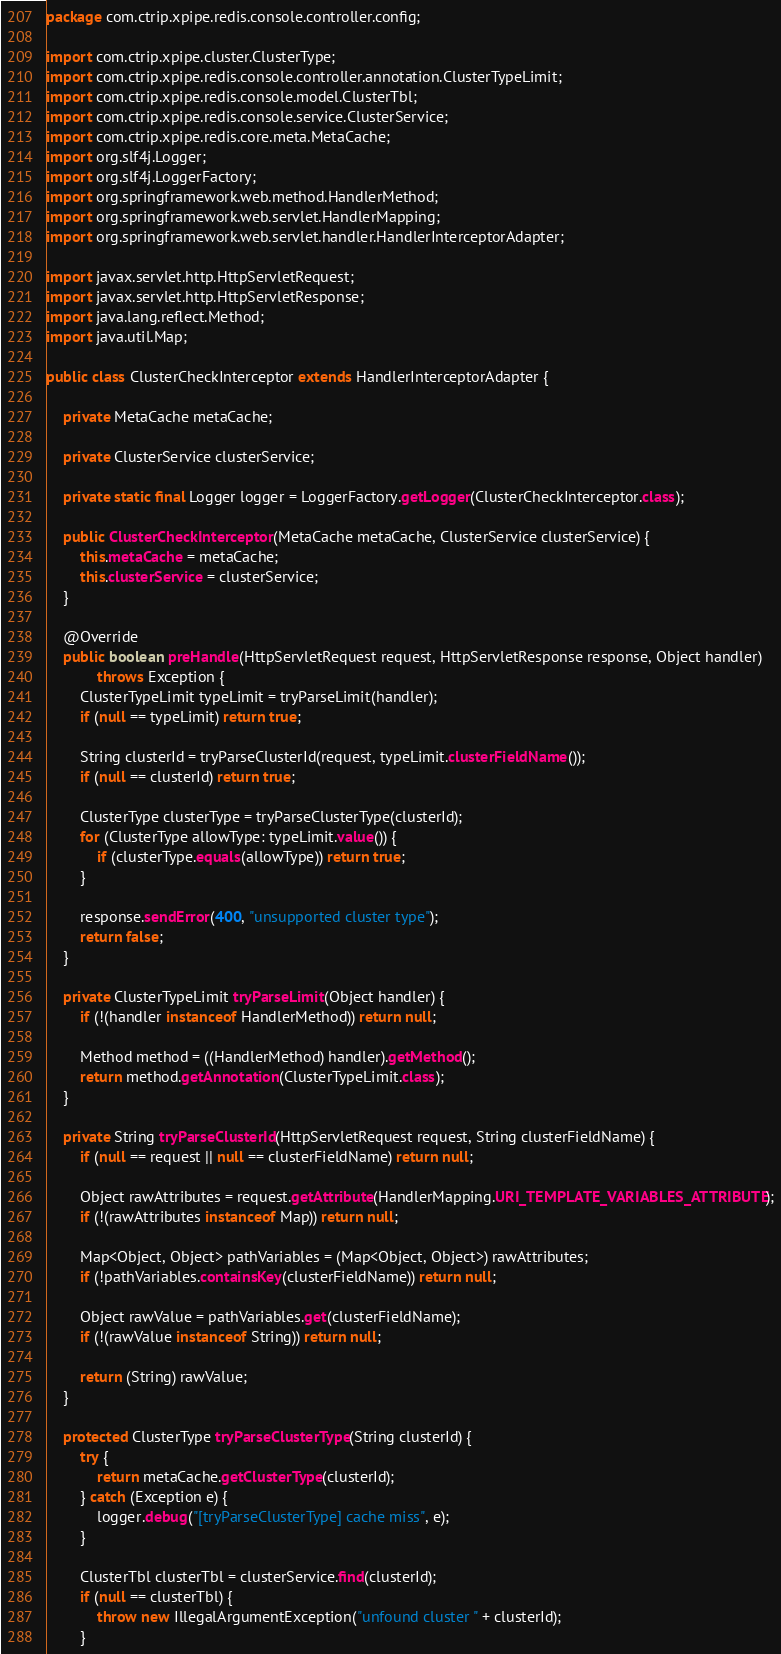<code> <loc_0><loc_0><loc_500><loc_500><_Java_>package com.ctrip.xpipe.redis.console.controller.config;

import com.ctrip.xpipe.cluster.ClusterType;
import com.ctrip.xpipe.redis.console.controller.annotation.ClusterTypeLimit;
import com.ctrip.xpipe.redis.console.model.ClusterTbl;
import com.ctrip.xpipe.redis.console.service.ClusterService;
import com.ctrip.xpipe.redis.core.meta.MetaCache;
import org.slf4j.Logger;
import org.slf4j.LoggerFactory;
import org.springframework.web.method.HandlerMethod;
import org.springframework.web.servlet.HandlerMapping;
import org.springframework.web.servlet.handler.HandlerInterceptorAdapter;

import javax.servlet.http.HttpServletRequest;
import javax.servlet.http.HttpServletResponse;
import java.lang.reflect.Method;
import java.util.Map;

public class ClusterCheckInterceptor extends HandlerInterceptorAdapter {

    private MetaCache metaCache;

    private ClusterService clusterService;

    private static final Logger logger = LoggerFactory.getLogger(ClusterCheckInterceptor.class);

    public ClusterCheckInterceptor(MetaCache metaCache, ClusterService clusterService) {
        this.metaCache = metaCache;
        this.clusterService = clusterService;
    }

    @Override
    public boolean preHandle(HttpServletRequest request, HttpServletResponse response, Object handler)
            throws Exception {
        ClusterTypeLimit typeLimit = tryParseLimit(handler);
        if (null == typeLimit) return true;

        String clusterId = tryParseClusterId(request, typeLimit.clusterFieldName());
        if (null == clusterId) return true;

        ClusterType clusterType = tryParseClusterType(clusterId);
        for (ClusterType allowType: typeLimit.value()) {
            if (clusterType.equals(allowType)) return true;
        }

        response.sendError(400, "unsupported cluster type");
        return false;
    }

    private ClusterTypeLimit tryParseLimit(Object handler) {
        if (!(handler instanceof HandlerMethod)) return null;

        Method method = ((HandlerMethod) handler).getMethod();
        return method.getAnnotation(ClusterTypeLimit.class);
    }

    private String tryParseClusterId(HttpServletRequest request, String clusterFieldName) {
        if (null == request || null == clusterFieldName) return null;

        Object rawAttributes = request.getAttribute(HandlerMapping.URI_TEMPLATE_VARIABLES_ATTRIBUTE);
        if (!(rawAttributes instanceof Map)) return null;

        Map<Object, Object> pathVariables = (Map<Object, Object>) rawAttributes;
        if (!pathVariables.containsKey(clusterFieldName)) return null;

        Object rawValue = pathVariables.get(clusterFieldName);
        if (!(rawValue instanceof String)) return null;

        return (String) rawValue;
    }

    protected ClusterType tryParseClusterType(String clusterId) {
        try {
            return metaCache.getClusterType(clusterId);
        } catch (Exception e) {
            logger.debug("[tryParseClusterType] cache miss", e);
        }

        ClusterTbl clusterTbl = clusterService.find(clusterId);
        if (null == clusterTbl) {
            throw new IllegalArgumentException("unfound cluster " + clusterId);
        }
</code> 